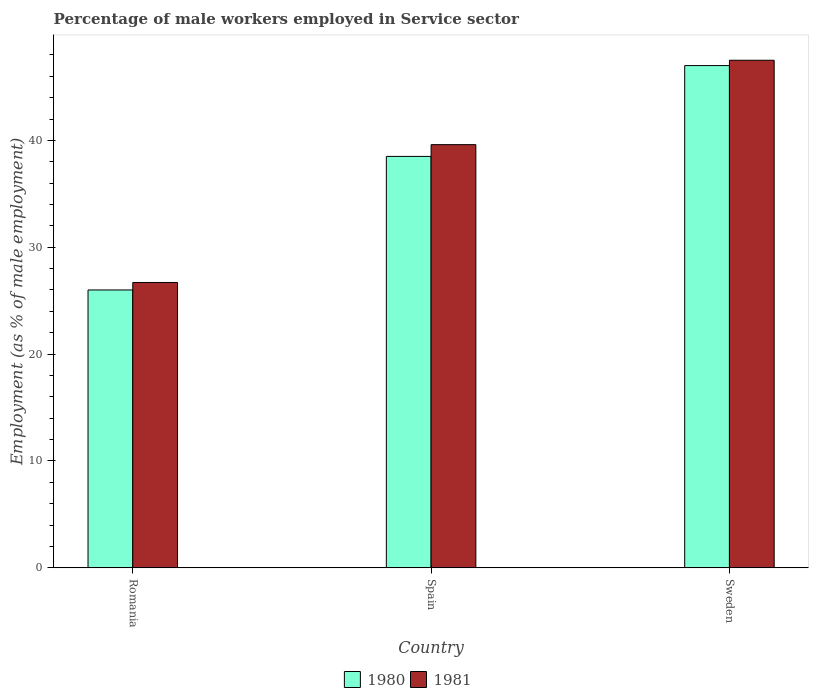How many different coloured bars are there?
Give a very brief answer. 2. Are the number of bars per tick equal to the number of legend labels?
Your answer should be very brief. Yes. Are the number of bars on each tick of the X-axis equal?
Make the answer very short. Yes. How many bars are there on the 1st tick from the left?
Ensure brevity in your answer.  2. What is the label of the 3rd group of bars from the left?
Your answer should be compact. Sweden. What is the percentage of male workers employed in Service sector in 1981 in Spain?
Your response must be concise. 39.6. Across all countries, what is the maximum percentage of male workers employed in Service sector in 1980?
Keep it short and to the point. 47. Across all countries, what is the minimum percentage of male workers employed in Service sector in 1981?
Make the answer very short. 26.7. In which country was the percentage of male workers employed in Service sector in 1981 minimum?
Offer a very short reply. Romania. What is the total percentage of male workers employed in Service sector in 1980 in the graph?
Ensure brevity in your answer.  111.5. What is the difference between the percentage of male workers employed in Service sector in 1981 in Romania and that in Sweden?
Ensure brevity in your answer.  -20.8. What is the difference between the percentage of male workers employed in Service sector in 1981 in Sweden and the percentage of male workers employed in Service sector in 1980 in Romania?
Your response must be concise. 21.5. What is the average percentage of male workers employed in Service sector in 1980 per country?
Provide a short and direct response. 37.17. What is the difference between the percentage of male workers employed in Service sector of/in 1981 and percentage of male workers employed in Service sector of/in 1980 in Spain?
Provide a short and direct response. 1.1. In how many countries, is the percentage of male workers employed in Service sector in 1981 greater than 16 %?
Give a very brief answer. 3. What is the ratio of the percentage of male workers employed in Service sector in 1981 in Romania to that in Sweden?
Provide a succinct answer. 0.56. Is the difference between the percentage of male workers employed in Service sector in 1981 in Romania and Spain greater than the difference between the percentage of male workers employed in Service sector in 1980 in Romania and Spain?
Give a very brief answer. No. What is the difference between the highest and the second highest percentage of male workers employed in Service sector in 1980?
Ensure brevity in your answer.  -12.5. What is the difference between the highest and the lowest percentage of male workers employed in Service sector in 1980?
Your response must be concise. 21. In how many countries, is the percentage of male workers employed in Service sector in 1981 greater than the average percentage of male workers employed in Service sector in 1981 taken over all countries?
Your response must be concise. 2. What does the 2nd bar from the left in Romania represents?
Offer a terse response. 1981. Are all the bars in the graph horizontal?
Your answer should be very brief. No. How many countries are there in the graph?
Offer a very short reply. 3. What is the difference between two consecutive major ticks on the Y-axis?
Ensure brevity in your answer.  10. Are the values on the major ticks of Y-axis written in scientific E-notation?
Make the answer very short. No. Does the graph contain any zero values?
Your answer should be compact. No. How many legend labels are there?
Offer a very short reply. 2. What is the title of the graph?
Your answer should be very brief. Percentage of male workers employed in Service sector. Does "2000" appear as one of the legend labels in the graph?
Give a very brief answer. No. What is the label or title of the X-axis?
Make the answer very short. Country. What is the label or title of the Y-axis?
Provide a short and direct response. Employment (as % of male employment). What is the Employment (as % of male employment) in 1981 in Romania?
Give a very brief answer. 26.7. What is the Employment (as % of male employment) of 1980 in Spain?
Provide a short and direct response. 38.5. What is the Employment (as % of male employment) in 1981 in Spain?
Offer a terse response. 39.6. What is the Employment (as % of male employment) in 1980 in Sweden?
Your answer should be very brief. 47. What is the Employment (as % of male employment) in 1981 in Sweden?
Provide a short and direct response. 47.5. Across all countries, what is the maximum Employment (as % of male employment) in 1981?
Provide a succinct answer. 47.5. Across all countries, what is the minimum Employment (as % of male employment) of 1981?
Provide a succinct answer. 26.7. What is the total Employment (as % of male employment) of 1980 in the graph?
Give a very brief answer. 111.5. What is the total Employment (as % of male employment) in 1981 in the graph?
Your answer should be compact. 113.8. What is the difference between the Employment (as % of male employment) of 1981 in Romania and that in Spain?
Your answer should be very brief. -12.9. What is the difference between the Employment (as % of male employment) in 1981 in Romania and that in Sweden?
Provide a succinct answer. -20.8. What is the difference between the Employment (as % of male employment) in 1980 in Spain and that in Sweden?
Your response must be concise. -8.5. What is the difference between the Employment (as % of male employment) in 1980 in Romania and the Employment (as % of male employment) in 1981 in Sweden?
Your answer should be very brief. -21.5. What is the difference between the Employment (as % of male employment) of 1980 in Spain and the Employment (as % of male employment) of 1981 in Sweden?
Offer a terse response. -9. What is the average Employment (as % of male employment) in 1980 per country?
Your answer should be very brief. 37.17. What is the average Employment (as % of male employment) of 1981 per country?
Your answer should be compact. 37.93. What is the difference between the Employment (as % of male employment) of 1980 and Employment (as % of male employment) of 1981 in Spain?
Keep it short and to the point. -1.1. What is the ratio of the Employment (as % of male employment) in 1980 in Romania to that in Spain?
Give a very brief answer. 0.68. What is the ratio of the Employment (as % of male employment) of 1981 in Romania to that in Spain?
Keep it short and to the point. 0.67. What is the ratio of the Employment (as % of male employment) of 1980 in Romania to that in Sweden?
Offer a very short reply. 0.55. What is the ratio of the Employment (as % of male employment) of 1981 in Romania to that in Sweden?
Keep it short and to the point. 0.56. What is the ratio of the Employment (as % of male employment) in 1980 in Spain to that in Sweden?
Give a very brief answer. 0.82. What is the ratio of the Employment (as % of male employment) of 1981 in Spain to that in Sweden?
Keep it short and to the point. 0.83. What is the difference between the highest and the lowest Employment (as % of male employment) of 1981?
Your response must be concise. 20.8. 